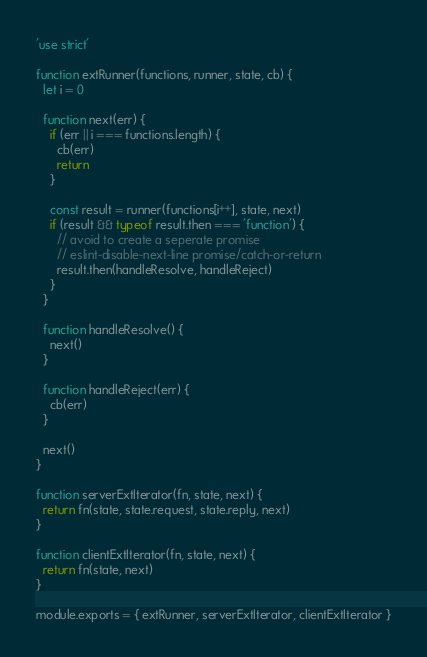<code> <loc_0><loc_0><loc_500><loc_500><_JavaScript_>'use strict'

function extRunner(functions, runner, state, cb) {
  let i = 0

  function next(err) {
    if (err || i === functions.length) {
      cb(err)
      return
    }

    const result = runner(functions[i++], state, next)
    if (result && typeof result.then === 'function') {
      // avoid to create a seperate promise
      // eslint-disable-next-line promise/catch-or-return
      result.then(handleResolve, handleReject)
    }
  }

  function handleResolve() {
    next()
  }

  function handleReject(err) {
    cb(err)
  }

  next()
}

function serverExtIterator(fn, state, next) {
  return fn(state, state.request, state.reply, next)
}

function clientExtIterator(fn, state, next) {
  return fn(state, next)
}

module.exports = { extRunner, serverExtIterator, clientExtIterator }
</code> 